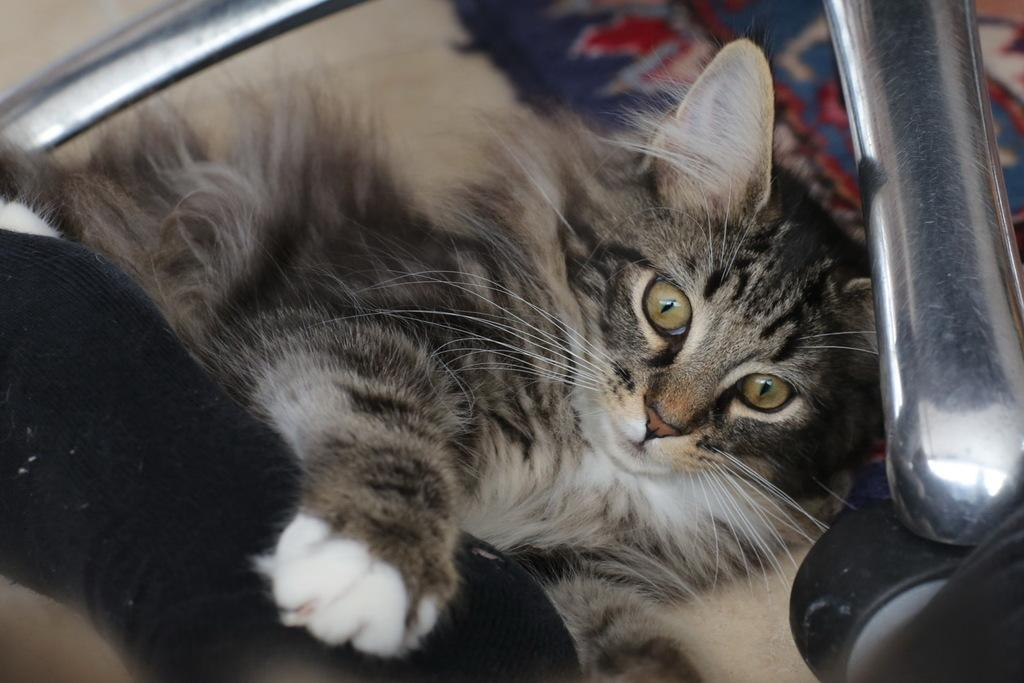What type of floor covering is visible in the image? There is a carpet on the floor in the image. What animal can be seen in the image? There is a cat in the image. What else is present on the floor in the image? There are objects on the floor in the image. What type of dress is the cat wearing in the image? There is no dress present in the image, and the cat is not wearing any clothing. What emotion is the cat expressing towards the objects on the floor in the image? The image does not depict the cat's emotions, so it cannot be determined how the cat feels about the objects on the floor. 